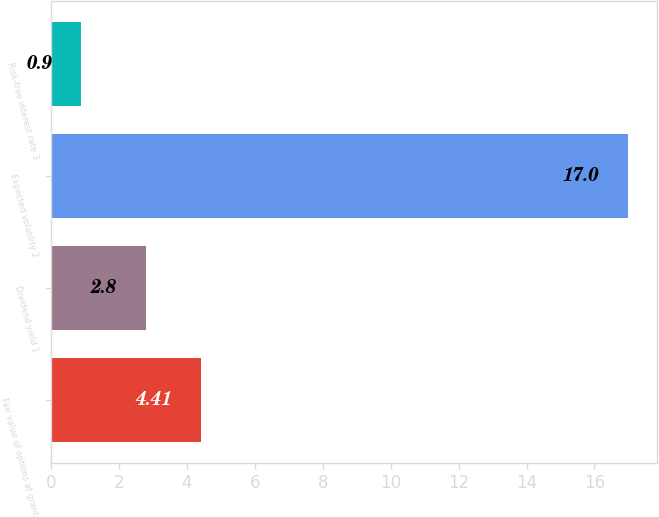Convert chart. <chart><loc_0><loc_0><loc_500><loc_500><bar_chart><fcel>Fair value of options at grant<fcel>Dividend yield 1<fcel>Expected volatility 2<fcel>Risk-free interest rate 3<nl><fcel>4.41<fcel>2.8<fcel>17<fcel>0.9<nl></chart> 